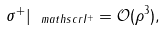<formula> <loc_0><loc_0><loc_500><loc_500>\sigma ^ { + } | _ { \ m a t h s c r { I } ^ { + } } = \mathcal { O } ( \rho ^ { 3 } ) ,</formula> 